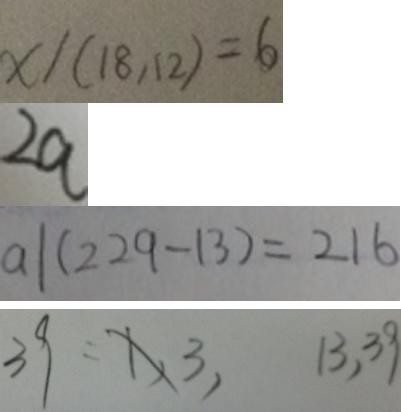<formula> <loc_0><loc_0><loc_500><loc_500>x / ( 1 8 , 1 2 ) = 6 
 2 a 
 a \vert ( 2 2 9 - 1 3 ) = 2 1 6 
 3 9 = 1 , 3 , 1 3 , 3 9</formula> 